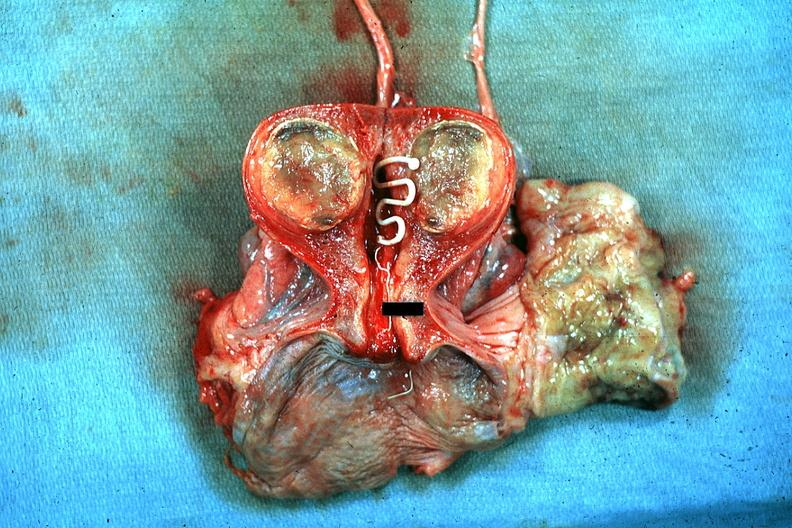s spina bifida present?
Answer the question using a single word or phrase. No 